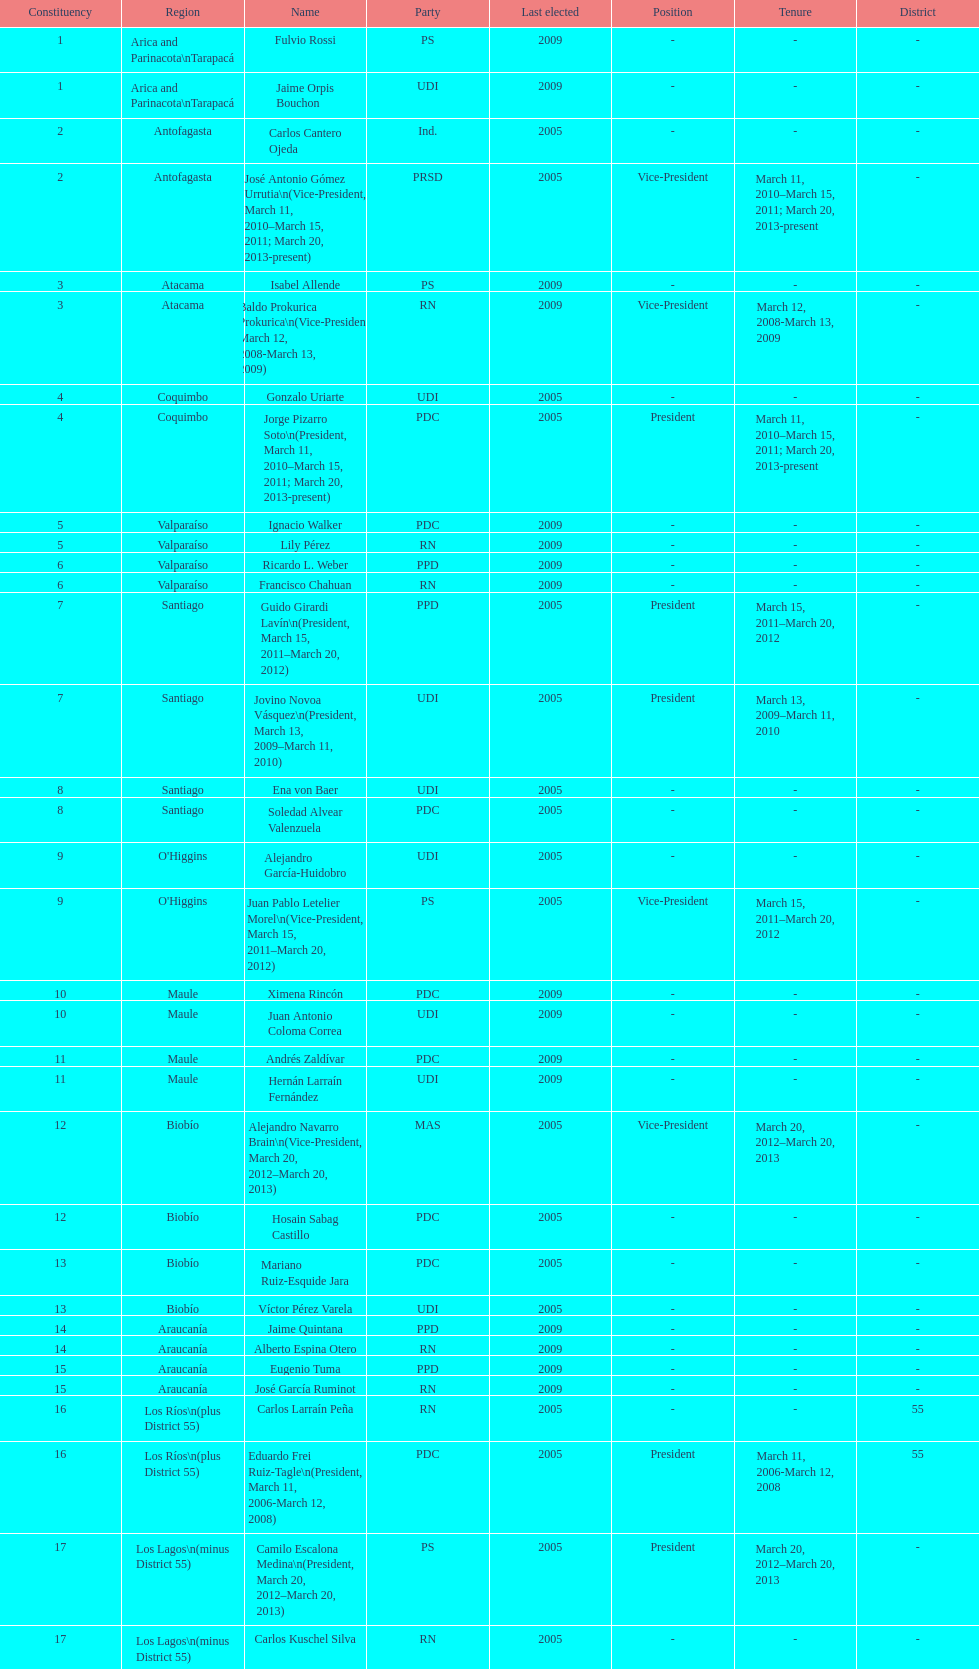Which party did jaime quintana belong to? PPD. 